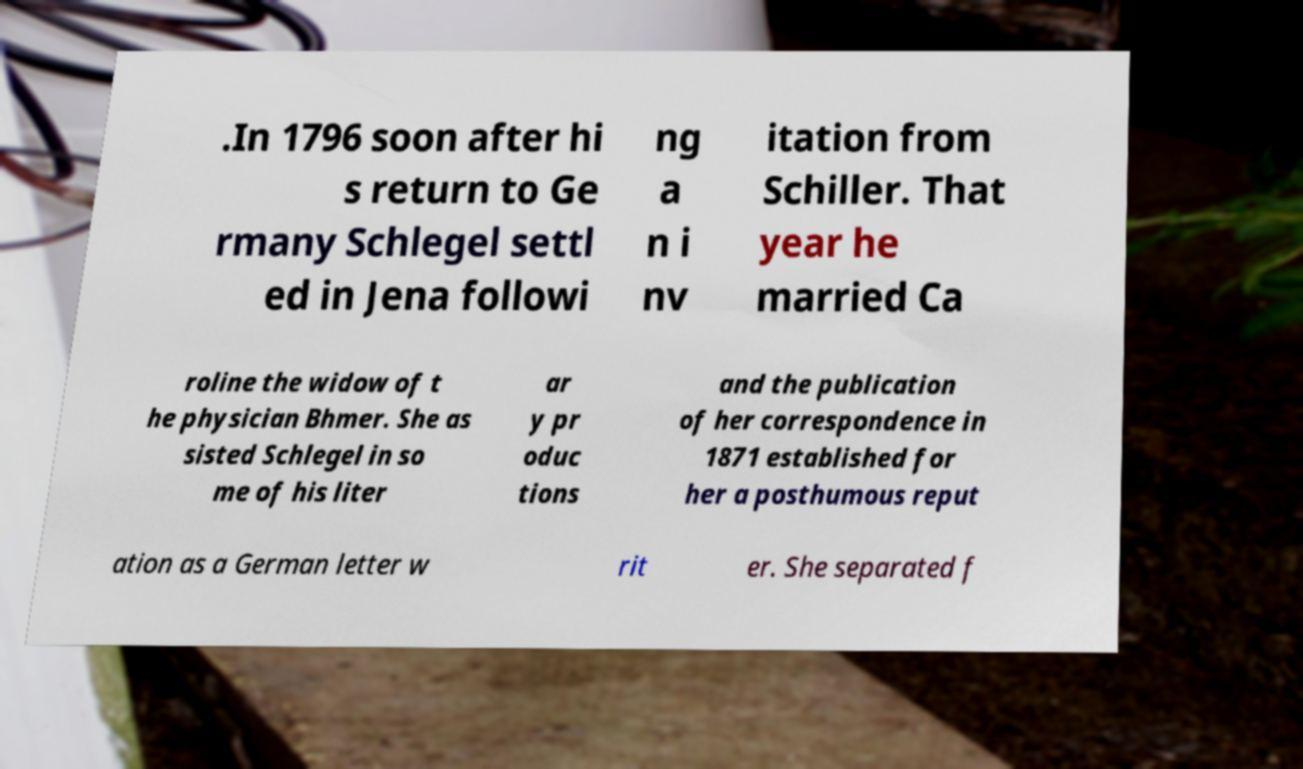Can you accurately transcribe the text from the provided image for me? .In 1796 soon after hi s return to Ge rmany Schlegel settl ed in Jena followi ng a n i nv itation from Schiller. That year he married Ca roline the widow of t he physician Bhmer. She as sisted Schlegel in so me of his liter ar y pr oduc tions and the publication of her correspondence in 1871 established for her a posthumous reput ation as a German letter w rit er. She separated f 